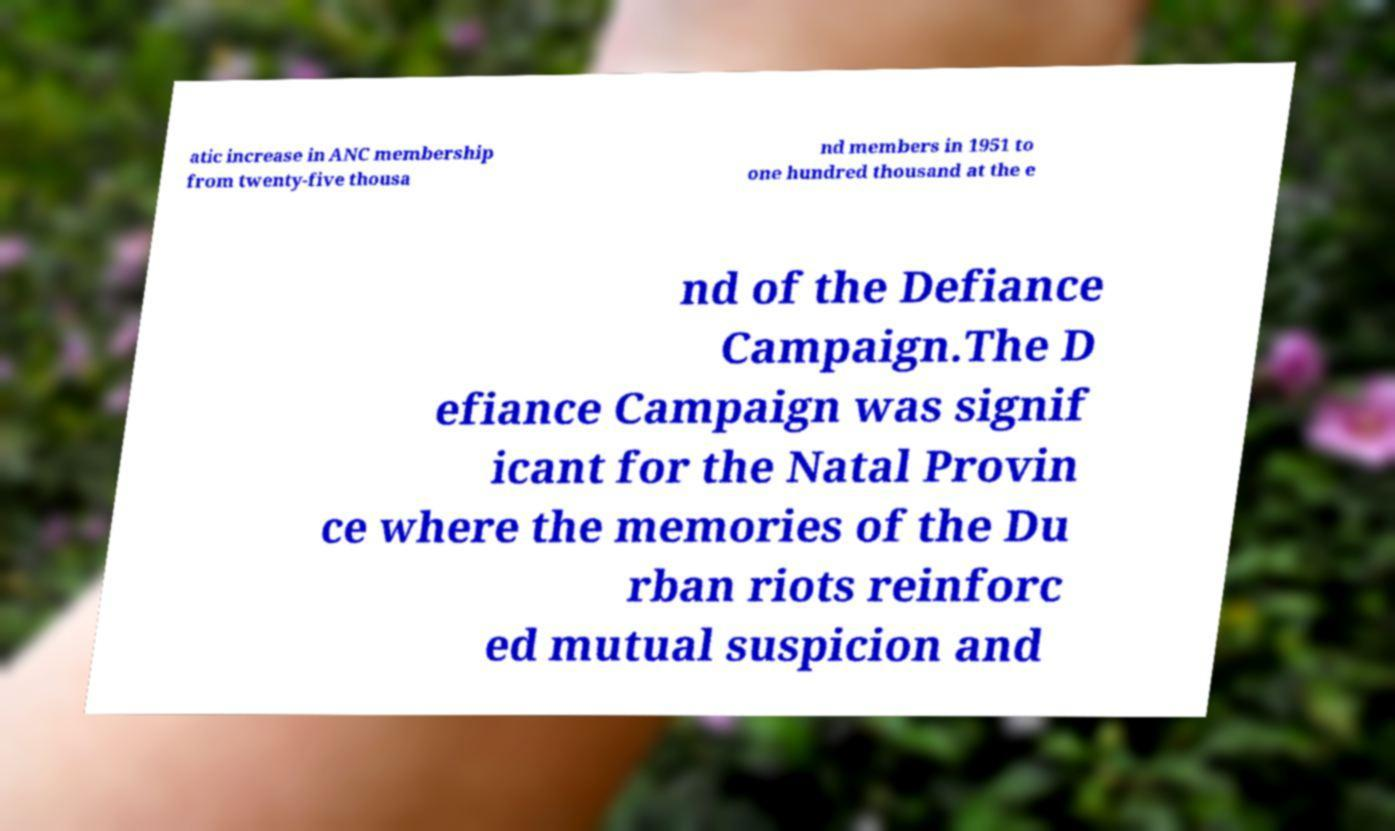Can you accurately transcribe the text from the provided image for me? atic increase in ANC membership from twenty-five thousa nd members in 1951 to one hundred thousand at the e nd of the Defiance Campaign.The D efiance Campaign was signif icant for the Natal Provin ce where the memories of the Du rban riots reinforc ed mutual suspicion and 